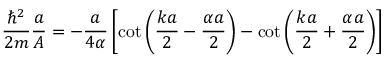Convert formula to latex. <formula><loc_0><loc_0><loc_500><loc_500>{ \frac { \hbar { ^ } { 2 } } { 2 m } } { \frac { a } { A } } = - { \frac { a } { 4 \alpha } } \left [ \cot \left ( { \frac { k a } { 2 } } - { \frac { \alpha a } { 2 } } \right ) - \cot \left ( { \frac { k a } { 2 } } + { \frac { \alpha a } { 2 } } \right ) \right ]</formula> 